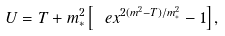<formula> <loc_0><loc_0><loc_500><loc_500>U = T + m _ { * } ^ { 2 } \left [ \ e x ^ { 2 ( m ^ { 2 } - T ) / m _ { * } ^ { 2 } } - 1 \right ] ,</formula> 